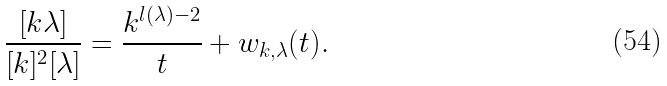Convert formula to latex. <formula><loc_0><loc_0><loc_500><loc_500>\frac { [ k \lambda ] } { [ k ] ^ { 2 } [ \lambda ] } = \frac { k ^ { l ( \lambda ) - 2 } } { t } + w _ { k , \lambda } ( t ) .</formula> 